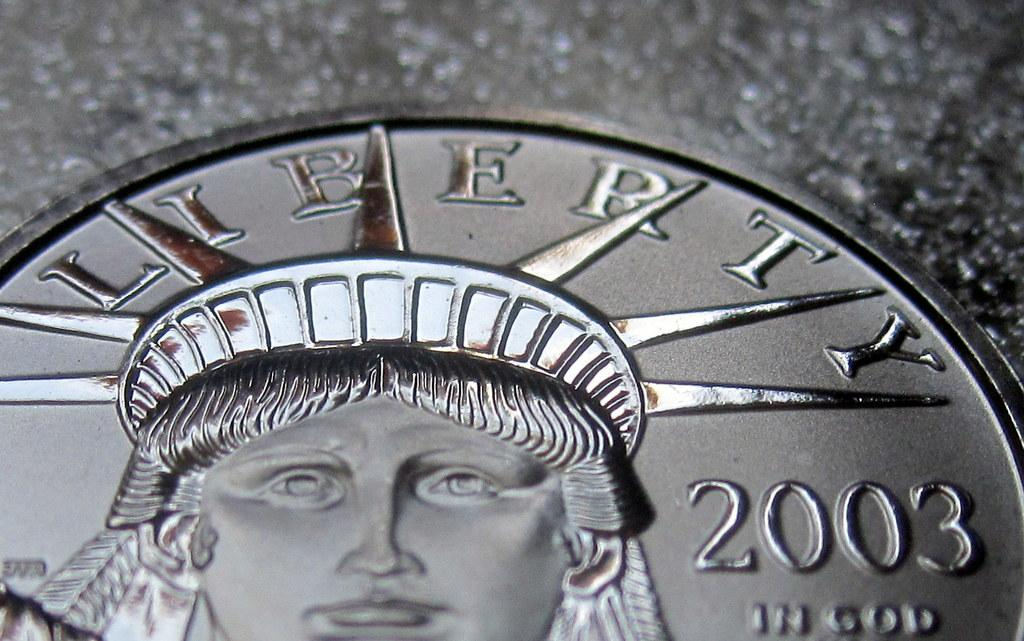<image>
Present a compact description of the photo's key features. Silver coin that says the year 2003 on the face. 